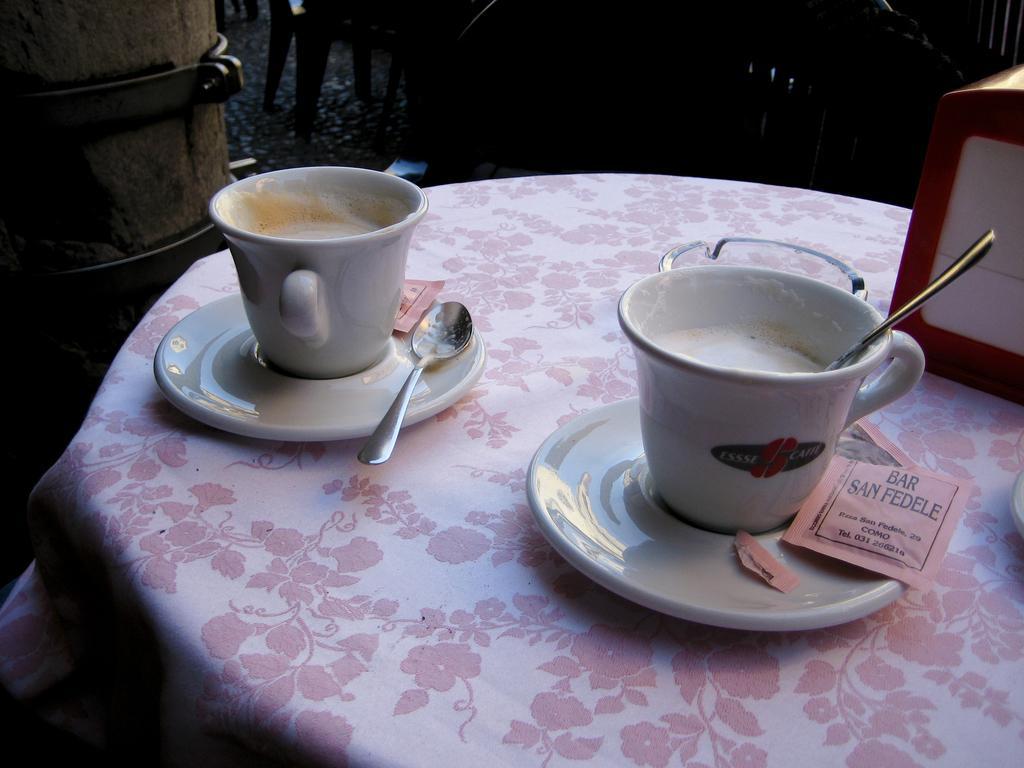Describe this image in one or two sentences. In this image we can see coffee in cup and spoons placed on the table. On the right side of the image we can see some object on the table. In the background there is a chair. 